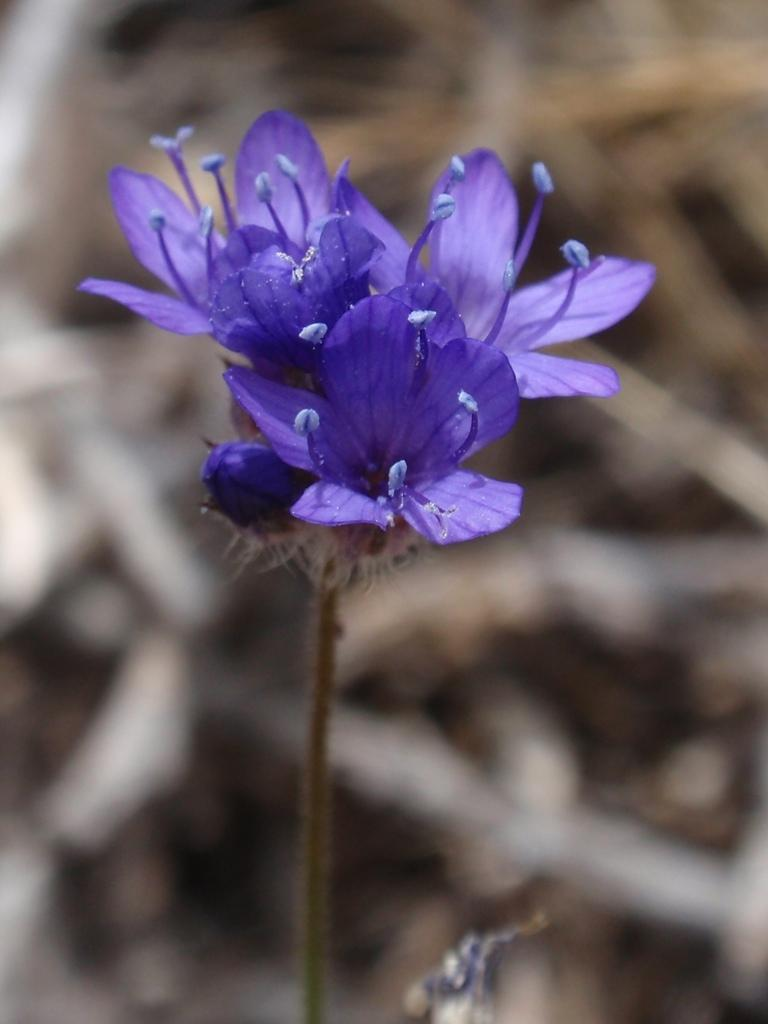What type of living organisms can be seen in the image? There are flowers in the image. Can you describe the background of the image? The background of the image is blurred. What type of cheese is being served as a meal in the image? There is no cheese or meal present in the image; it only features flowers and a blurred background. 